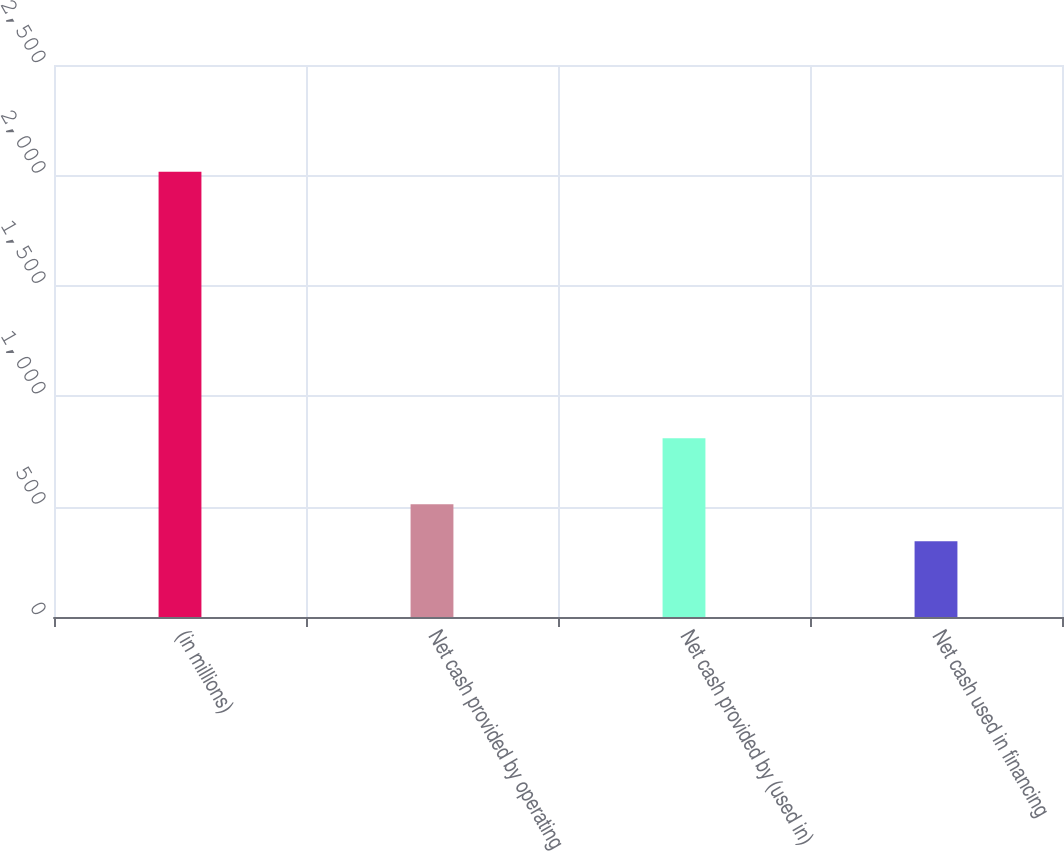<chart> <loc_0><loc_0><loc_500><loc_500><bar_chart><fcel>(in millions)<fcel>Net cash provided by operating<fcel>Net cash provided by (used in)<fcel>Net cash used in financing<nl><fcel>2016<fcel>510.48<fcel>809.5<fcel>343.2<nl></chart> 